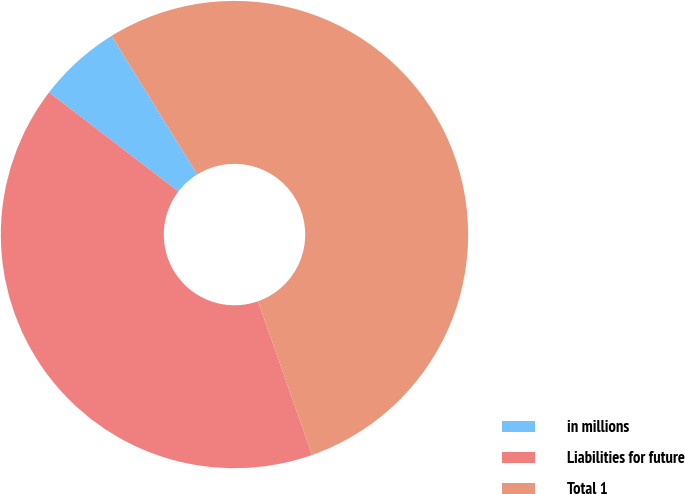Convert chart to OTSL. <chart><loc_0><loc_0><loc_500><loc_500><pie_chart><fcel>in millions<fcel>Liabilities for future<fcel>Total 1<nl><fcel>5.77%<fcel>40.8%<fcel>53.43%<nl></chart> 